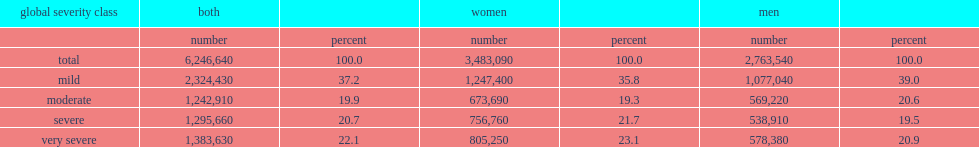What percent of the 6.2 million canadians aged 15 years and over with a disability were classified as having a mild disability. 37.2. What percent of total canadians aged 15 years and over with a disability had a moderate disability? 19.9. What percent of total canadians aged 15 years and over with a disability had a severe disability? 20.7. What percent of total canadians aged 15 years and over with a disability had a very severe disability? 22.1. Which group of people is more likely to have mild disabilities? Women. 